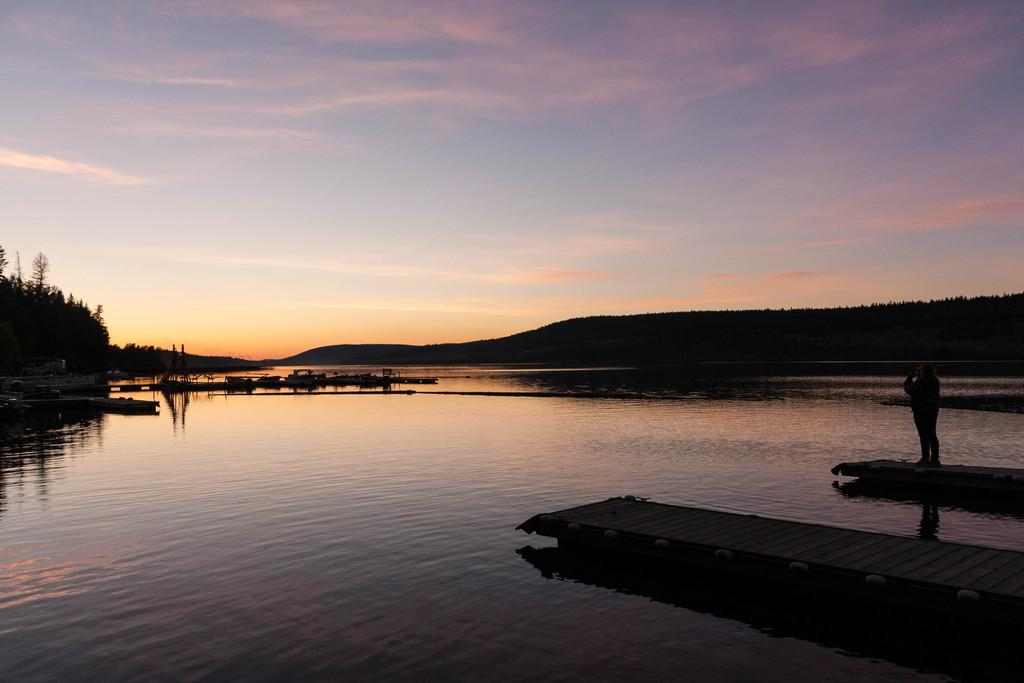What natural feature is located at the bottom of the image? There is a river at the bottom of the image. What is the person on the right side of the image doing? The person is standing on a board on the right side of the image. What type of vegetation is on the left side of the image? There are trees on the left side of the image. What is visible at the top of the image? The sky is visible at the top of the image. Where is the mailbox located in the image? There is no mailbox present in the image. What thought is the person on the board having in the image? There is no indication of the person's thoughts in the image. 